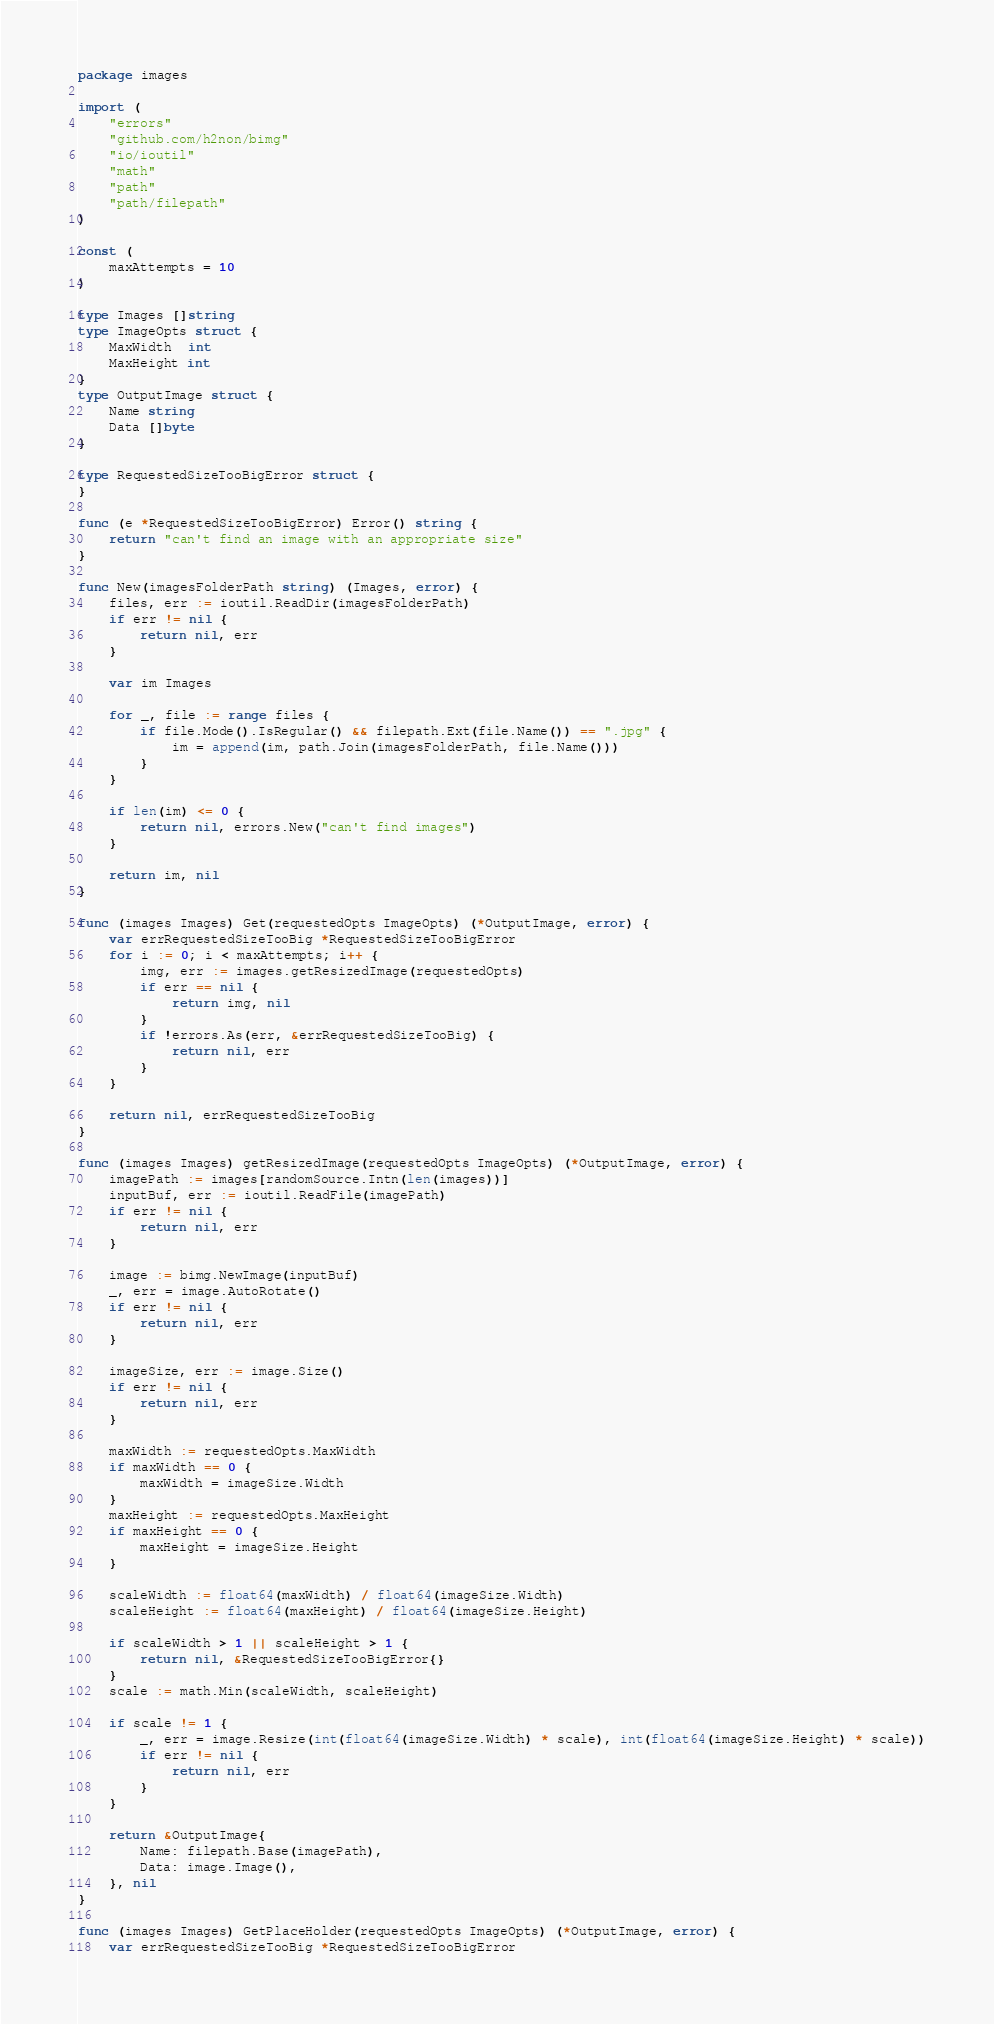Convert code to text. <code><loc_0><loc_0><loc_500><loc_500><_Go_>package images

import (
	"errors"
	"github.com/h2non/bimg"
	"io/ioutil"
	"math"
	"path"
	"path/filepath"
)

const (
	maxAttempts = 10
)

type Images []string
type ImageOpts struct {
	MaxWidth  int
	MaxHeight int
}
type OutputImage struct {
	Name string
	Data []byte
}

type RequestedSizeTooBigError struct {
}

func (e *RequestedSizeTooBigError) Error() string {
	return "can't find an image with an appropriate size"
}

func New(imagesFolderPath string) (Images, error) {
	files, err := ioutil.ReadDir(imagesFolderPath)
	if err != nil {
		return nil, err
	}

	var im Images

	for _, file := range files {
		if file.Mode().IsRegular() && filepath.Ext(file.Name()) == ".jpg" {
			im = append(im, path.Join(imagesFolderPath, file.Name()))
		}
	}

	if len(im) <= 0 {
		return nil, errors.New("can't find images")
	}

	return im, nil
}

func (images Images) Get(requestedOpts ImageOpts) (*OutputImage, error) {
	var errRequestedSizeTooBig *RequestedSizeTooBigError
	for i := 0; i < maxAttempts; i++ {
		img, err := images.getResizedImage(requestedOpts)
		if err == nil {
			return img, nil
		}
		if !errors.As(err, &errRequestedSizeTooBig) {
			return nil, err
		}
	}

	return nil, errRequestedSizeTooBig
}

func (images Images) getResizedImage(requestedOpts ImageOpts) (*OutputImage, error) {
	imagePath := images[randomSource.Intn(len(images))]
	inputBuf, err := ioutil.ReadFile(imagePath)
	if err != nil {
		return nil, err
	}

	image := bimg.NewImage(inputBuf)
	_, err = image.AutoRotate()
	if err != nil {
		return nil, err
	}

	imageSize, err := image.Size()
	if err != nil {
		return nil, err
	}

	maxWidth := requestedOpts.MaxWidth
	if maxWidth == 0 {
		maxWidth = imageSize.Width
	}
	maxHeight := requestedOpts.MaxHeight
	if maxHeight == 0 {
		maxHeight = imageSize.Height
	}

	scaleWidth := float64(maxWidth) / float64(imageSize.Width)
	scaleHeight := float64(maxHeight) / float64(imageSize.Height)

	if scaleWidth > 1 || scaleHeight > 1 {
		return nil, &RequestedSizeTooBigError{}
	}
	scale := math.Min(scaleWidth, scaleHeight)

	if scale != 1 {
		_, err = image.Resize(int(float64(imageSize.Width) * scale), int(float64(imageSize.Height) * scale))
		if err != nil {
			return nil, err
		}
	}

	return &OutputImage{
		Name: filepath.Base(imagePath),
		Data: image.Image(),
	}, nil
}

func (images Images) GetPlaceHolder(requestedOpts ImageOpts) (*OutputImage, error) {
	var errRequestedSizeTooBig *RequestedSizeTooBigError</code> 